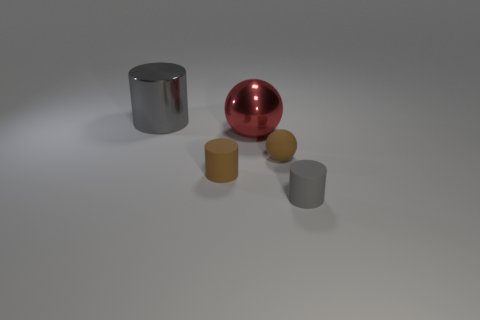Can you infer context or purpose for these objects? Without additional context, it is challenging to determine a specific purpose for these objects from the image alone. They could possibly be used for illustrative purposes in a demonstration about geometry, reflections, and textures, or as decorative items within an abstract art composition. 